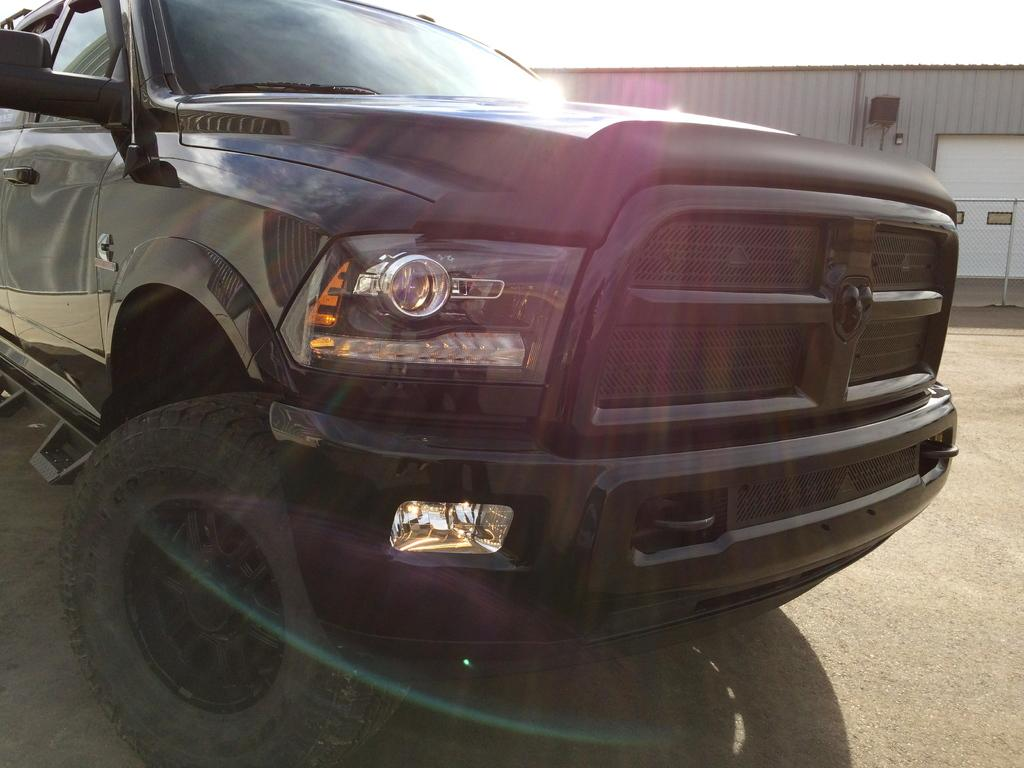What is the main subject of the image? The main subject of the image is a car. What is the car doing in the image? The car is parked in the image. What can be seen in the background of the image? There is a house and a fence in the background of the image. Can you see any celery growing near the car in the image? There is no celery present in the image. What type of frame surrounds the car in the image? The image does not show a frame surrounding the car. 